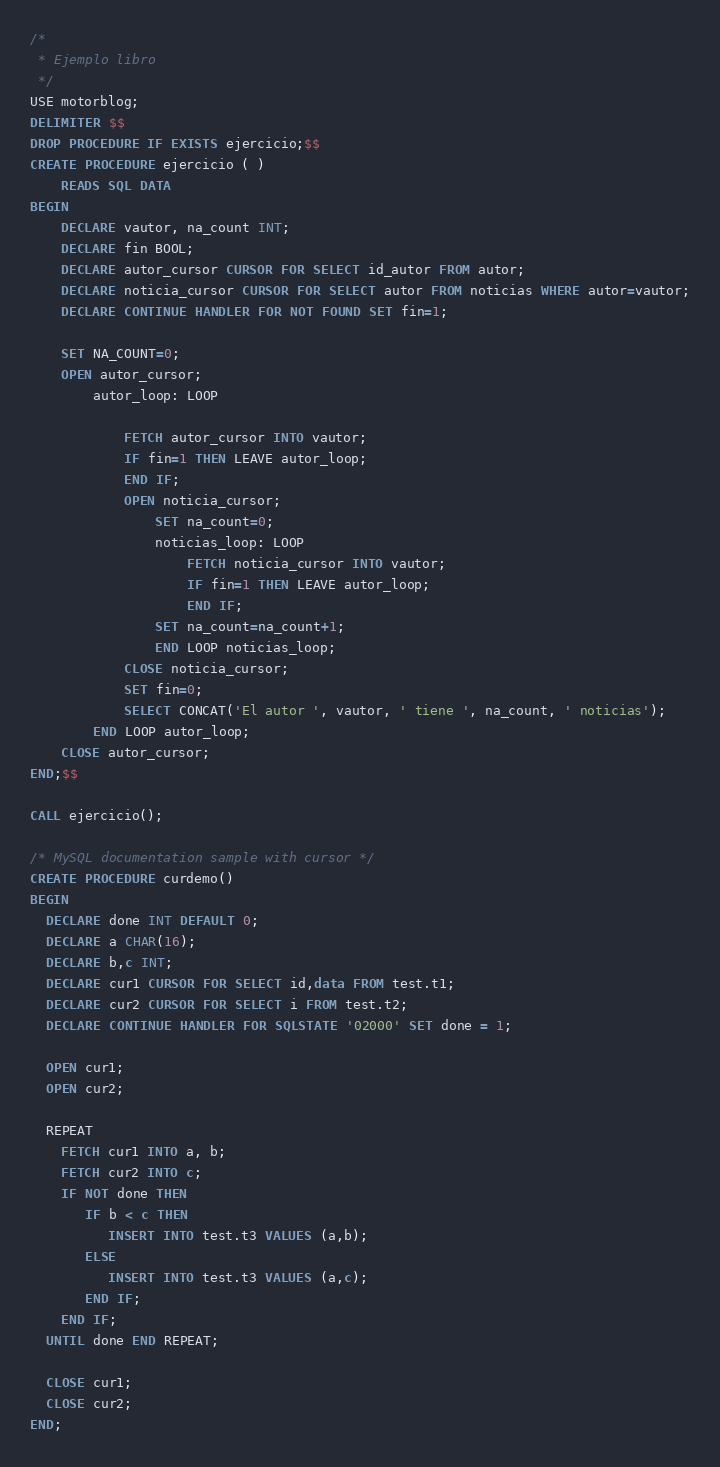<code> <loc_0><loc_0><loc_500><loc_500><_SQL_>/* 
 * Ejemplo libro
 */
USE motorblog;
DELIMITER $$
DROP PROCEDURE IF EXISTS ejercicio;$$ 
CREATE PROCEDURE ejercicio ( )
    READS SQL DATA
BEGIN
    DECLARE vautor, na_count INT;
    DECLARE fin BOOL;
    DECLARE autor_cursor CURSOR FOR SELECT id_autor FROM autor;
    DECLARE noticia_cursor CURSOR FOR SELECT autor FROM noticias WHERE autor=vautor;
    DECLARE CONTINUE HANDLER FOR NOT FOUND SET fin=1;
    
    SET NA_COUNT=0;
    OPEN autor_cursor;
        autor_loop: LOOP
      
            FETCH autor_cursor INTO vautor;
            IF fin=1 THEN LEAVE autor_loop;
            END IF;
            OPEN noticia_cursor; 
                SET na_count=0;
                noticias_loop: LOOP
                    FETCH noticia_cursor INTO vautor;
                    IF fin=1 THEN LEAVE autor_loop;
                    END IF;
                SET na_count=na_count+1;
                END LOOP noticias_loop;
            CLOSE noticia_cursor;
            SET fin=0;
            SELECT CONCAT('El autor ', vautor, ' tiene ', na_count, ' noticias');
        END LOOP autor_loop;
    CLOSE autor_cursor;
END;$$

CALL ejercicio();

/* MySQL documentation sample with cursor */
CREATE PROCEDURE curdemo()
BEGIN
  DECLARE done INT DEFAULT 0;
  DECLARE a CHAR(16);
  DECLARE b,c INT;
  DECLARE cur1 CURSOR FOR SELECT id,data FROM test.t1;
  DECLARE cur2 CURSOR FOR SELECT i FROM test.t2;
  DECLARE CONTINUE HANDLER FOR SQLSTATE '02000' SET done = 1;

  OPEN cur1;
  OPEN cur2;

  REPEAT
    FETCH cur1 INTO a, b;
    FETCH cur2 INTO c;
    IF NOT done THEN
       IF b < c THEN
          INSERT INTO test.t3 VALUES (a,b);
       ELSE
          INSERT INTO test.t3 VALUES (a,c);
       END IF;
    END IF;
  UNTIL done END REPEAT;

  CLOSE cur1;
  CLOSE cur2;
END;</code> 